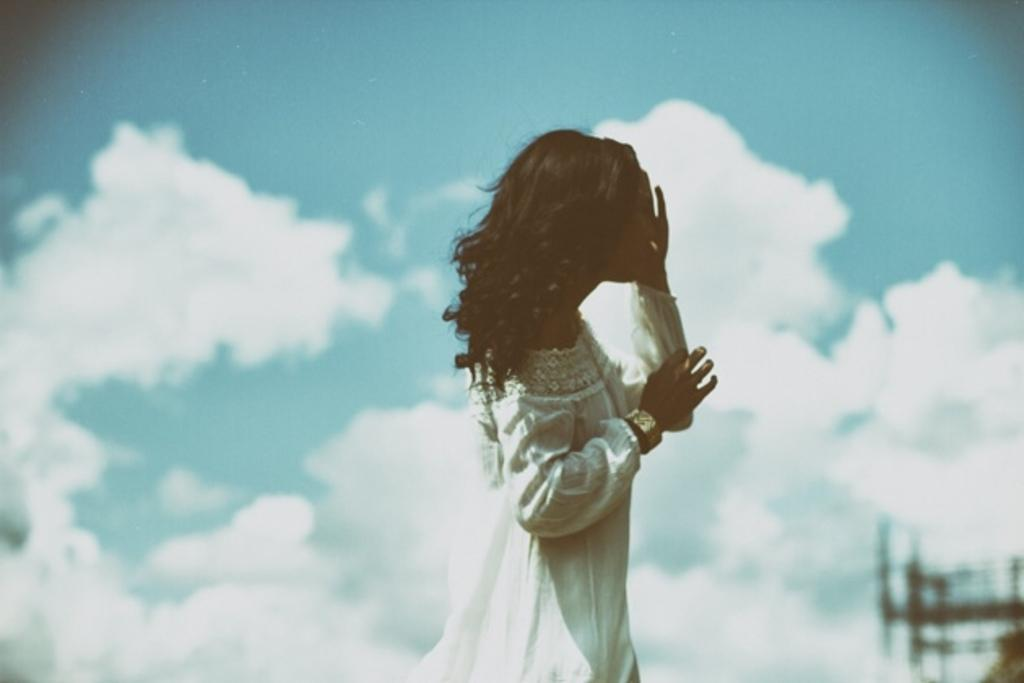Who is the main subject in the image? There is a lady in the image. What is the lady wearing? The lady is wearing a white dress and a bangle. What can be seen in the background of the image? There is sky visible in the background of the image. What is the condition of the sky in the image? There are clouds in the sky. Where is the store located in the image? There is no store present in the image. What type of shelf can be seen in the image? There is no shelf present in the image. 